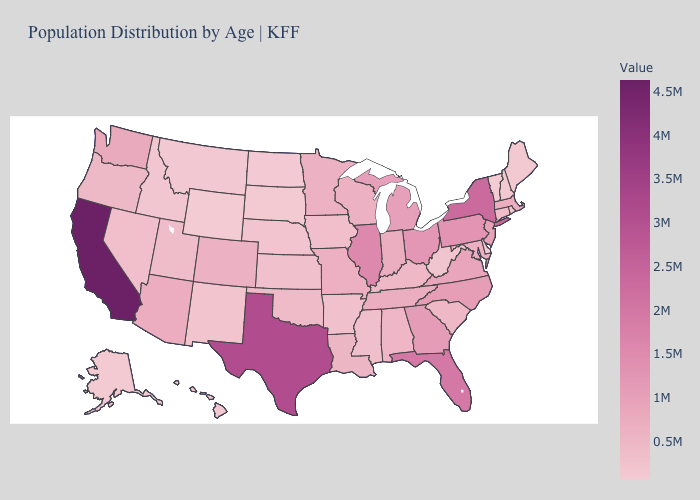Among the states that border Arkansas , which have the highest value?
Answer briefly. Texas. Is the legend a continuous bar?
Keep it brief. Yes. Among the states that border Oklahoma , which have the highest value?
Concise answer only. Texas. Does California have the lowest value in the USA?
Quick response, please. No. Among the states that border Texas , which have the lowest value?
Quick response, please. New Mexico. Does Vermont have the lowest value in the Northeast?
Give a very brief answer. Yes. 